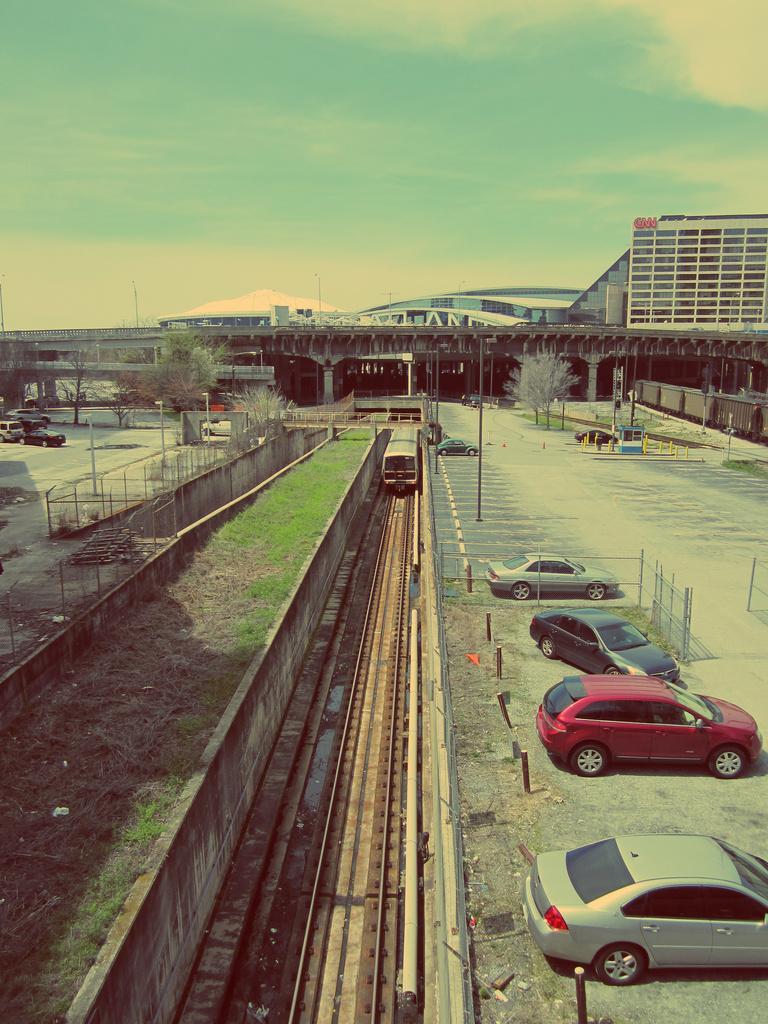Please provide a concise description of this image. In this image we can see a group of cars parked on the ground. In the center of the image we can see a locomotive on a track, fence, we can also see some poles. In the background, we can see a bridge and a group of buildings. At the top of the image we can see the sky. 